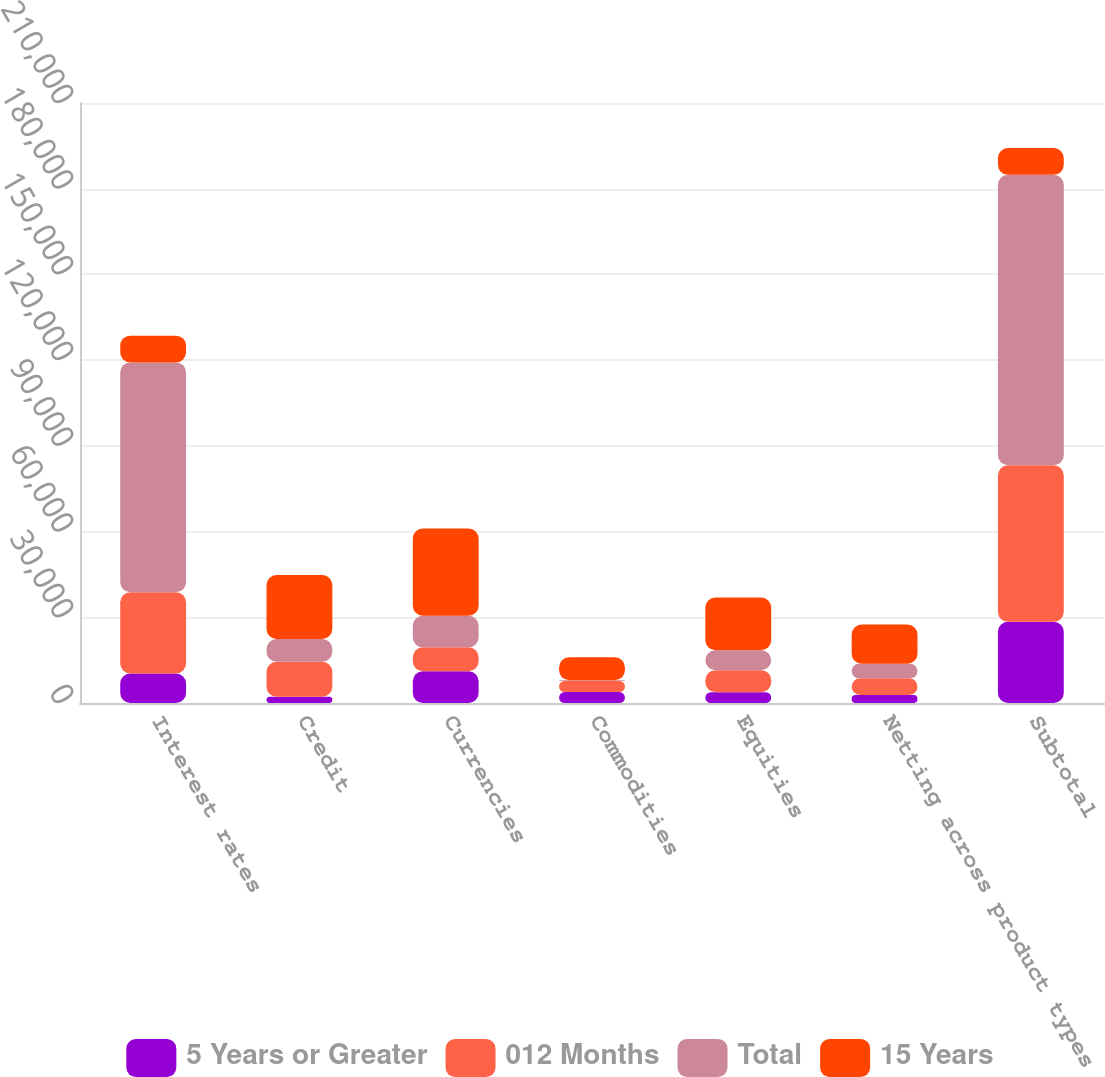Convert chart. <chart><loc_0><loc_0><loc_500><loc_500><stacked_bar_chart><ecel><fcel>Interest rates<fcel>Credit<fcel>Currencies<fcel>Commodities<fcel>Equities<fcel>Netting across product types<fcel>Subtotal<nl><fcel>5 Years or Greater<fcel>10318<fcel>2190<fcel>11100<fcel>3840<fcel>3757<fcel>2811<fcel>28394<nl><fcel>012 Months<fcel>28445<fcel>12244<fcel>8379<fcel>3862<fcel>7730<fcel>5831<fcel>54829<nl><fcel>Total<fcel>80449<fcel>7970<fcel>11044<fcel>304<fcel>6957<fcel>5082<fcel>101642<nl><fcel>15 Years<fcel>9348.5<fcel>22404<fcel>30523<fcel>8006<fcel>18444<fcel>13724<fcel>9348.5<nl></chart> 